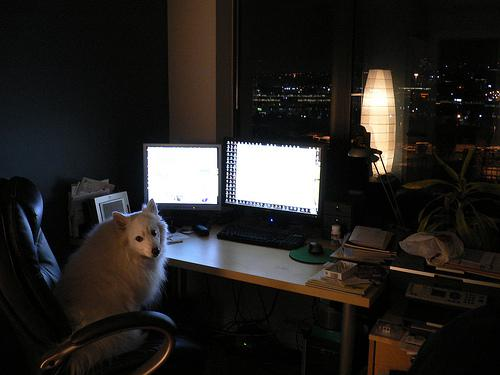Question: what color is the desk?
Choices:
A. Brown.
B. Beige.
C. White.
D. Gold..
Answer with the letter. Answer: B Question: when was the picture taken?
Choices:
A. At night.
B. In the morning.
C. In the afternoon.
D. At breakfast.
Answer with the letter. Answer: A Question: who took the picture?
Choices:
A. The mother of the children.
B. The babysitter.
C. The loft owner.
D. The insurance adjustor.
Answer with the letter. Answer: C 